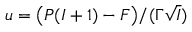Convert formula to latex. <formula><loc_0><loc_0><loc_500><loc_500>u = \left ( P ( I + 1 ) - F \right ) / ( \Gamma \sqrt { I } )</formula> 